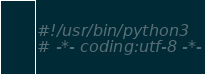<code> <loc_0><loc_0><loc_500><loc_500><_Python_>#!/usr/bin/python3
# -*- coding:utf-8 -*-

</code> 